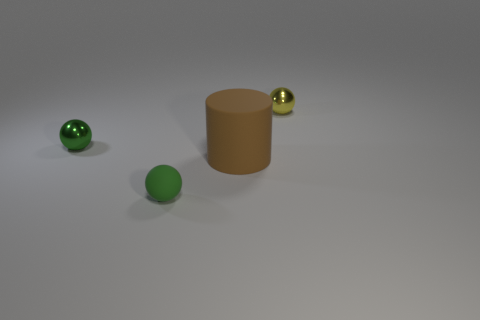How many other objects are the same size as the brown matte cylinder?
Ensure brevity in your answer.  0. Is the number of brown matte things less than the number of small red matte spheres?
Your answer should be compact. No. The green rubber thing has what shape?
Your answer should be very brief. Sphere. Do the sphere that is behind the green metallic thing and the small matte object have the same color?
Your answer should be compact. No. There is a tiny object that is both behind the big brown object and on the left side of the big brown cylinder; what shape is it?
Your response must be concise. Sphere. What is the color of the metallic object that is on the right side of the rubber cylinder?
Make the answer very short. Yellow. Is there any other thing of the same color as the tiny matte ball?
Your answer should be compact. Yes. Is the size of the green rubber ball the same as the brown matte cylinder?
Your answer should be very brief. No. What size is the ball that is both in front of the yellow shiny object and on the right side of the tiny green shiny sphere?
Your answer should be very brief. Small. How many tiny green things have the same material as the yellow ball?
Your answer should be very brief. 1. 